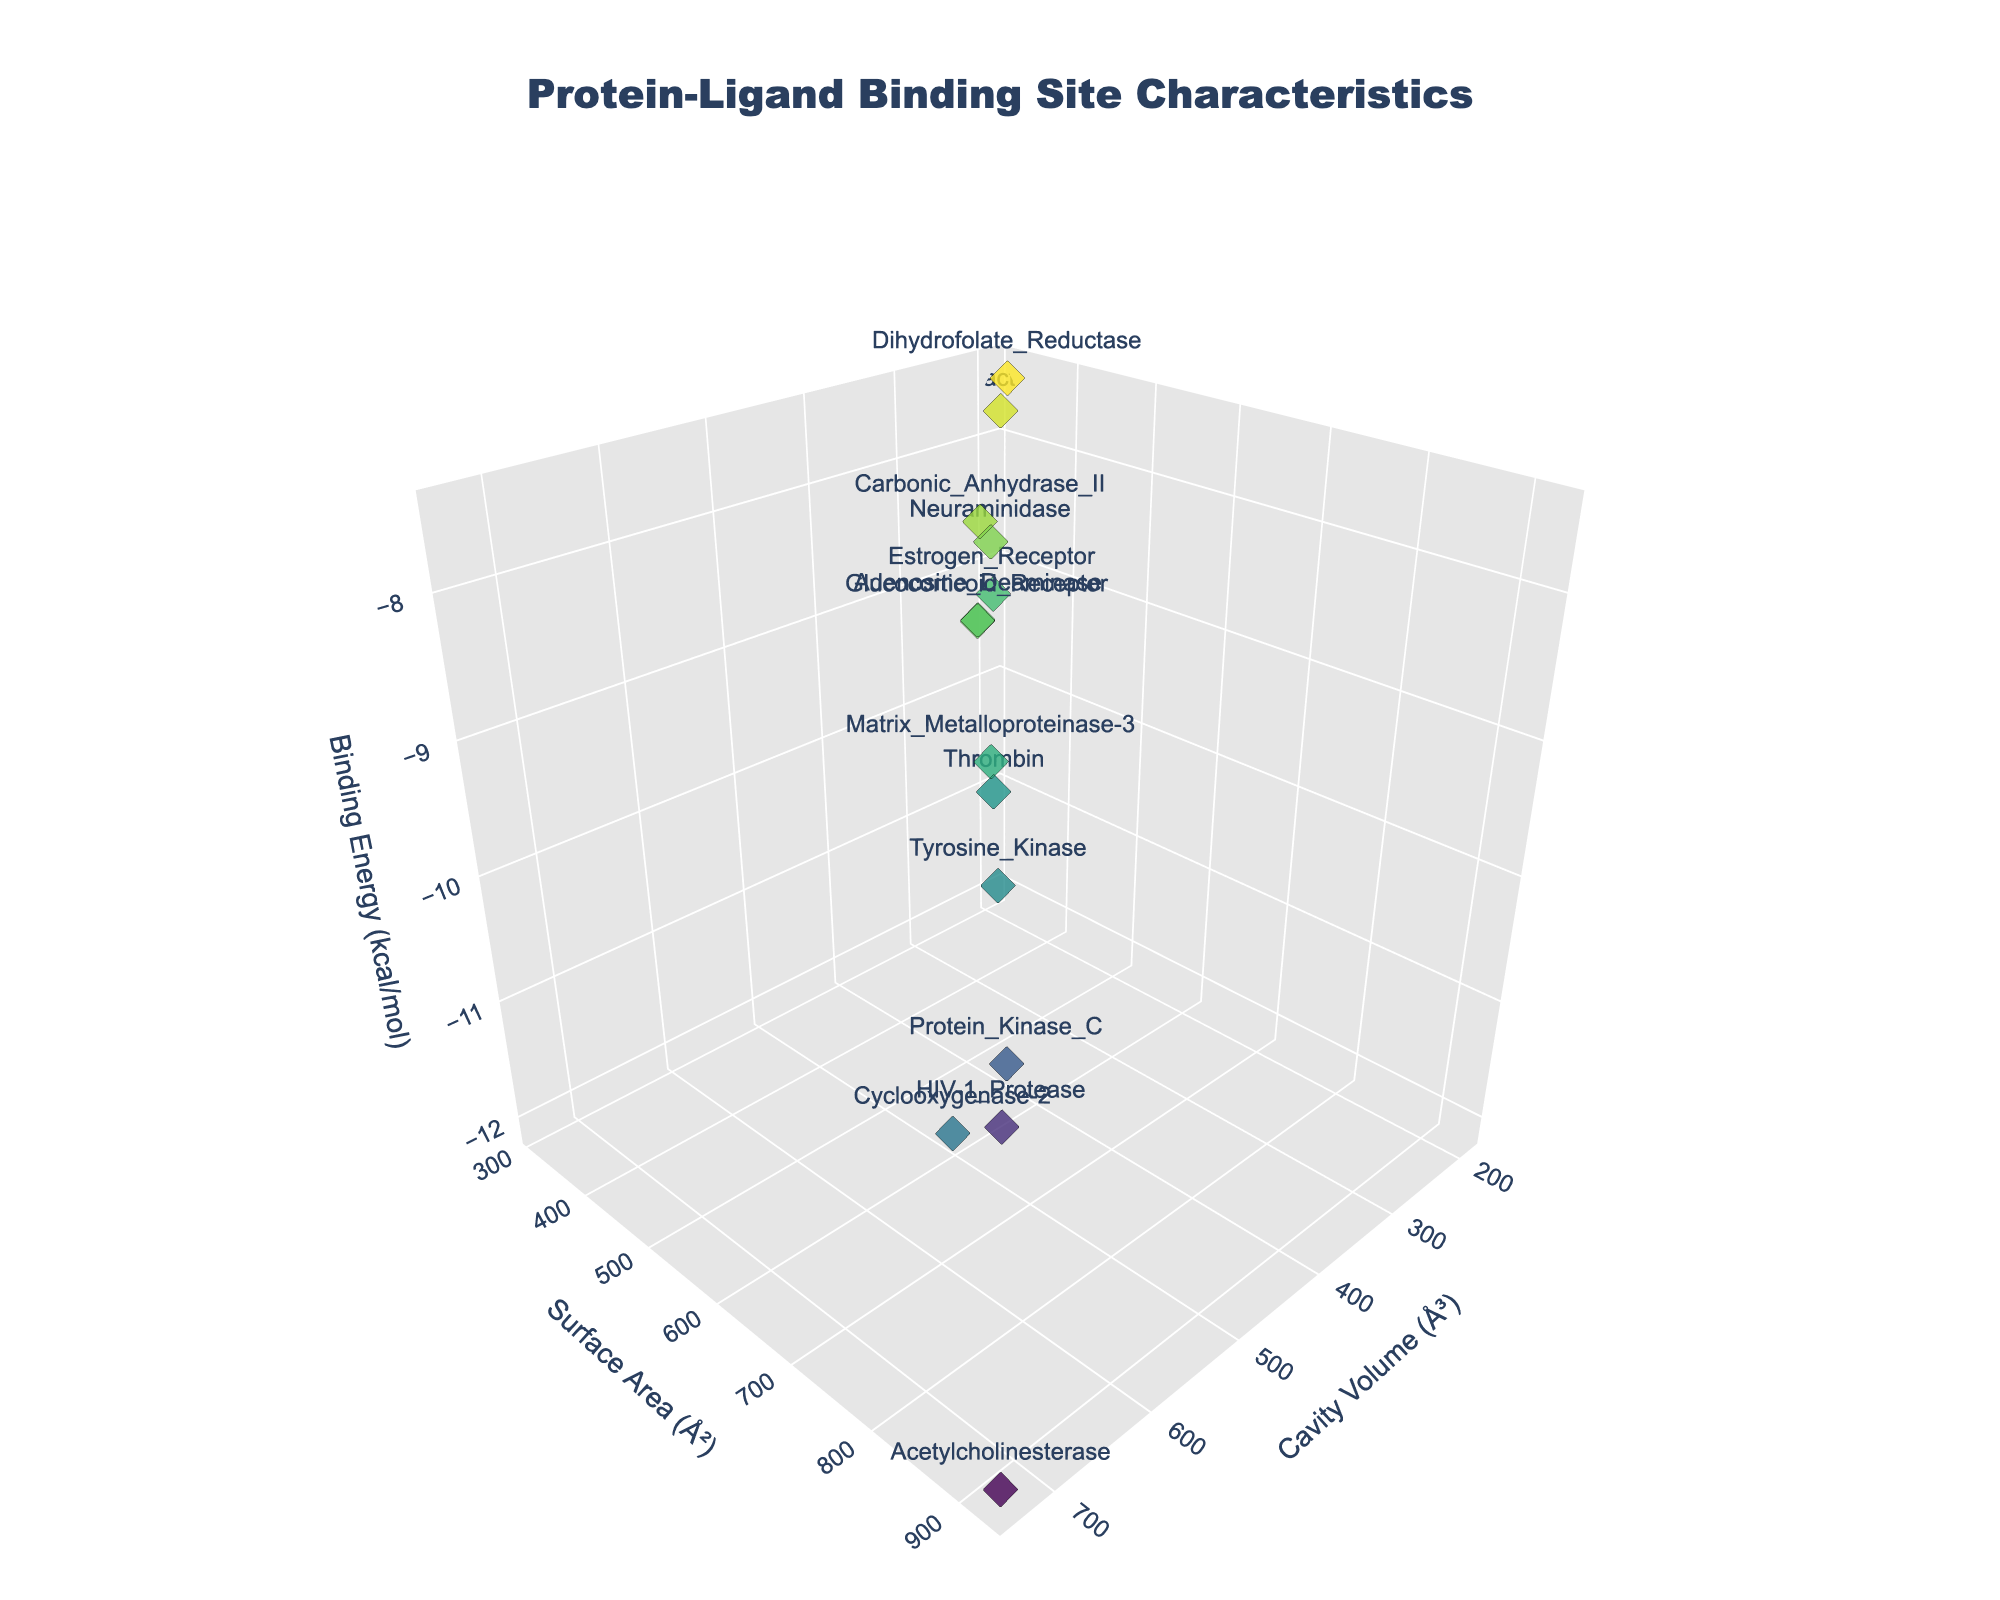What is the title of the 3D scatter plot? The title of the plot is shown at the top of the figure. It reads "Protein-Ligand Binding Site Characteristics", indicating the topic of the plot.
Answer: Protein-Ligand Binding Site Characteristics How many proteins are represented in the plot? Each marker in the 3D scatter plot represents one protein. By counting the markers or referring to the hover text, we can see that there are 14 proteins.
Answer: 14 Which protein has the highest cavity volume? Examine the x-axis for the highest value and identify the corresponding protein by its marker or hover text. "Acetylcholinesterase" has the highest cavity volume at 735 Å³.
Answer: Acetylcholinesterase What are the binding energy ranges for the proteins shown in the plot? Look at the z-axis which represents the binding energy. The range can be observed from the markers' position on this axis. The binding energy ranges from -7.5 to -12.1 kcal/mol.
Answer: -7.5 to -12.1 kcal/mol Which protein has the lowest surface area, and what is its binding energy? Locate the protein with the lowest value on the y-axis (surface area), identify it, and note its z-coordinate (binding energy). "Beta-Lactamase" has the lowest surface area at 312 Å² and its binding energy is -7.8 kcal/mol.
Answer: Beta-Lactamase, -7.8 kcal/mol Do proteins with higher cavity volumes tend to have higher or lower binding energies? To answer this, examine the scatter plot to see if markers with higher x-values (cavity volume) cluster at higher or lower z-values (binding energy). Proteins with higher cavity volumes tend to have lower (more negative) binding energies.
Answer: Lower Which protein shows the best overall binding efficiency considering low binding energy and high cavity volume? Ideal proteins will have a low (most negative) z-value and high x-value. "Acetylcholinesterase" has the highest cavity volume at 735 Å³ and a binding energy of -12.1 kcal/mol, indicating high binding efficiency.
Answer: Acetylcholinesterase What is the average surface area of all proteins shown? Sum all surface area values and divide by the number of proteins. (427 + 689 + 312 + 553 + 812 + 398 + 924 + 335 + 602 + 507 + 715 + 421 + 643 + 482) / 14 = 568 Å²
Answer: 568 Å² Is there a correlation between cavity volume and surface area? By visually inspecting the scatter plot, observe if higher x-values (cavity volume) generally correspond with higher y-values (surface area). There appears to be a positive correlation between cavity volume and surface area.
Answer: Yes Compare the binding energy of HIV-1 Protease and Estrogen Receptor. Which one has a more negative binding energy? Check the z-values (binding energy) for both proteins. HIV-1 Protease has a binding energy of -11.5 kcal/mol, while Estrogen Receptor has -8.9 kcal/mol. HIV-1 Protease has a more negative binding energy.
Answer: HIV-1 Protease 